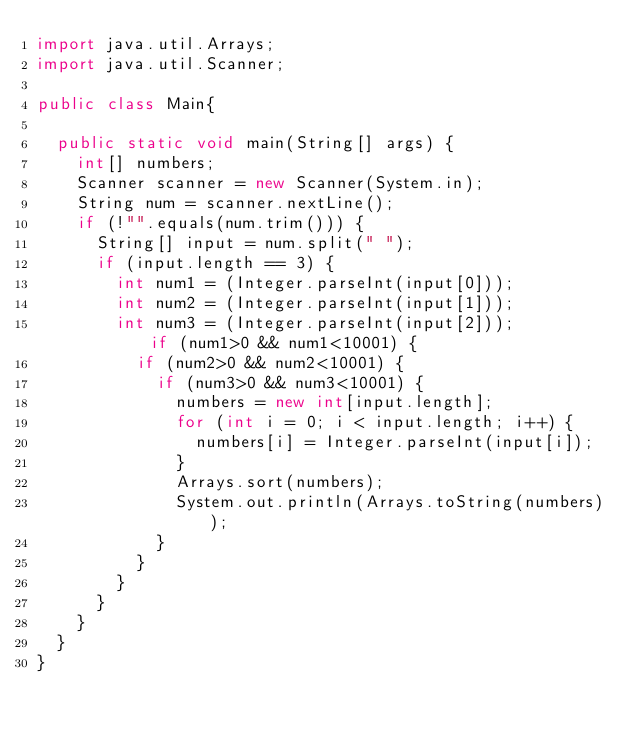Convert code to text. <code><loc_0><loc_0><loc_500><loc_500><_Java_>import java.util.Arrays;
import java.util.Scanner;

public class Main{

	public static void main(String[] args) {
		int[] numbers;
		Scanner scanner = new Scanner(System.in);
		String num = scanner.nextLine();
		if (!"".equals(num.trim())) {
			String[] input = num.split(" ");
			if (input.length == 3) {
				int num1 = (Integer.parseInt(input[0]));
				int num2 = (Integer.parseInt(input[1]));
				int num3 = (Integer.parseInt(input[2]));				if (num1>0 && num1<10001) {
					if (num2>0 && num2<10001) {
						if (num3>0 && num3<10001) {
							numbers = new int[input.length];
							for (int i = 0; i < input.length; i++) {
								numbers[i] = Integer.parseInt(input[i]);
							}
							Arrays.sort(numbers);
							System.out.println(Arrays.toString(numbers));
						}
					}
				}
			}
		}
	}
}</code> 